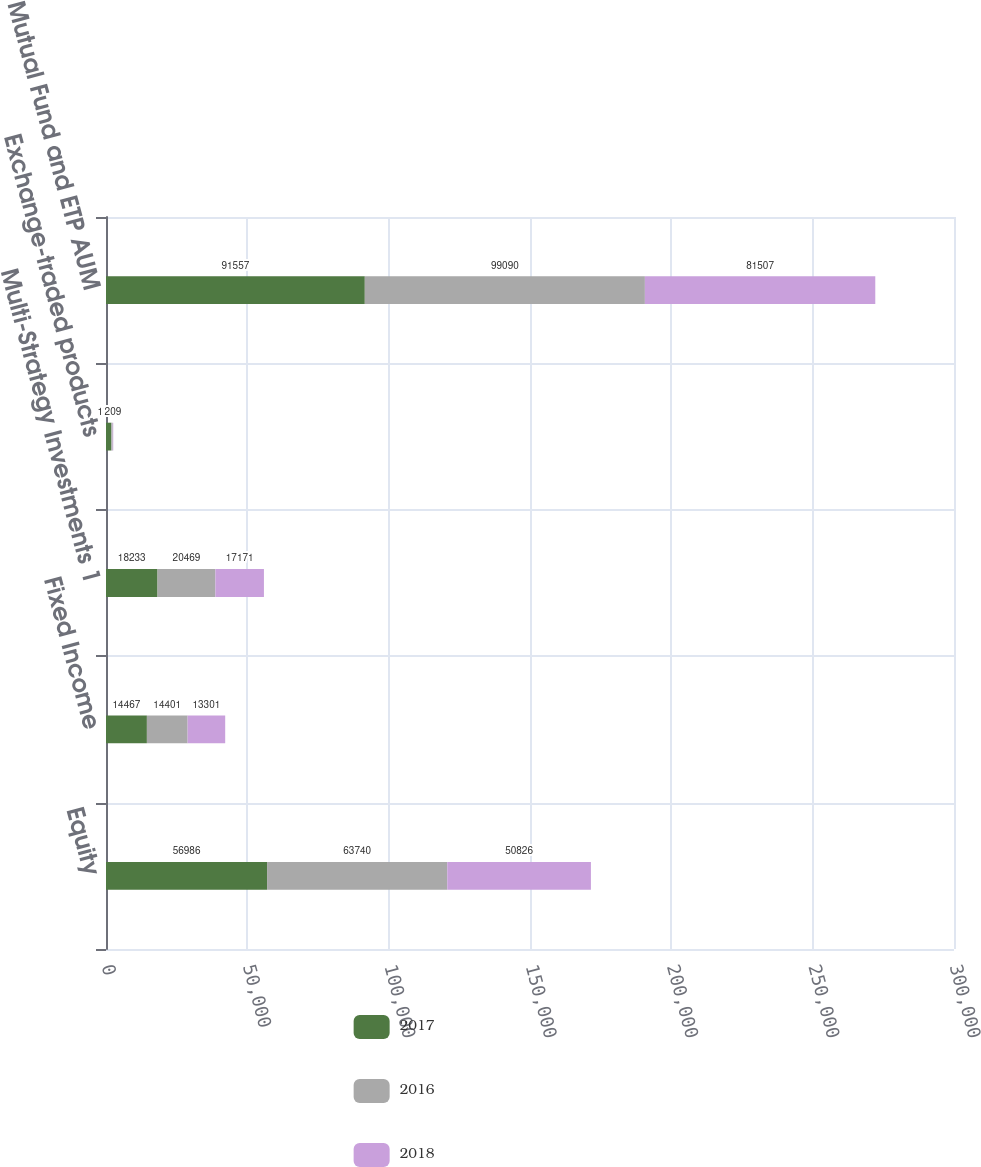Convert chart to OTSL. <chart><loc_0><loc_0><loc_500><loc_500><stacked_bar_chart><ecel><fcel>Equity<fcel>Fixed Income<fcel>Multi-Strategy Investments 1<fcel>Exchange-traded products<fcel>Mutual Fund and ETP AUM<nl><fcel>2017<fcel>56986<fcel>14467<fcel>18233<fcel>1871<fcel>91557<nl><fcel>2016<fcel>63740<fcel>14401<fcel>20469<fcel>480<fcel>99090<nl><fcel>2018<fcel>50826<fcel>13301<fcel>17171<fcel>209<fcel>81507<nl></chart> 